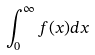Convert formula to latex. <formula><loc_0><loc_0><loc_500><loc_500>\int _ { 0 } ^ { \infty } f ( x ) d x</formula> 